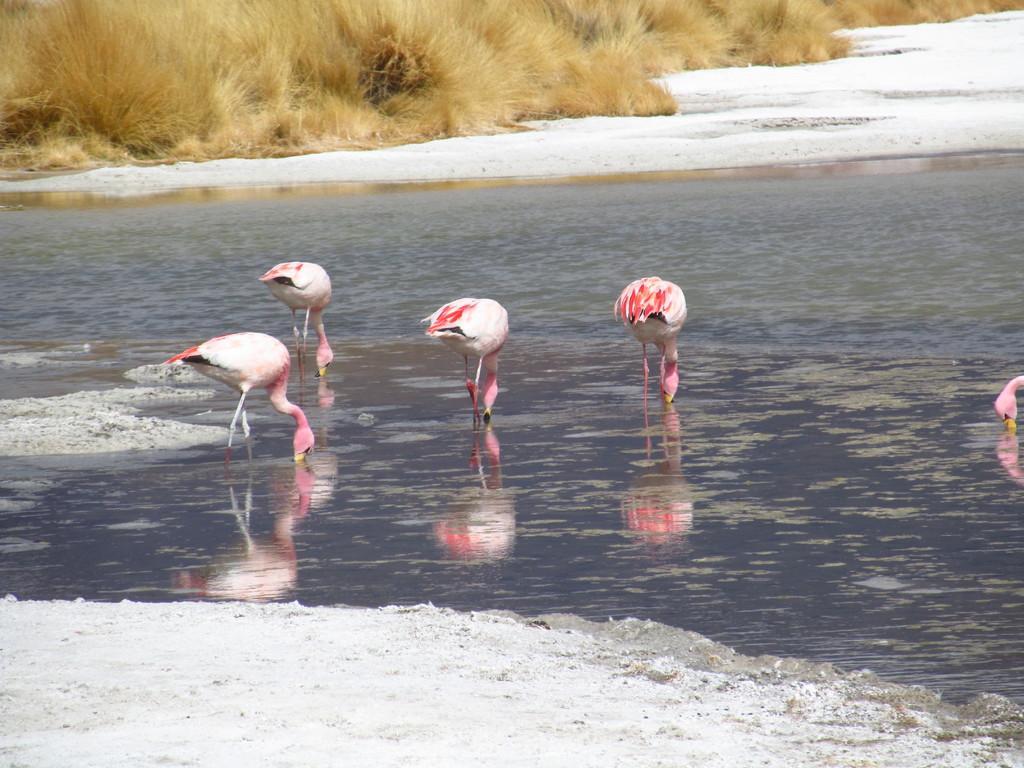Could you give a brief overview of what you see in this image? In this image we can see there are some birds in the water. At the top of the image there is a dry grass. 